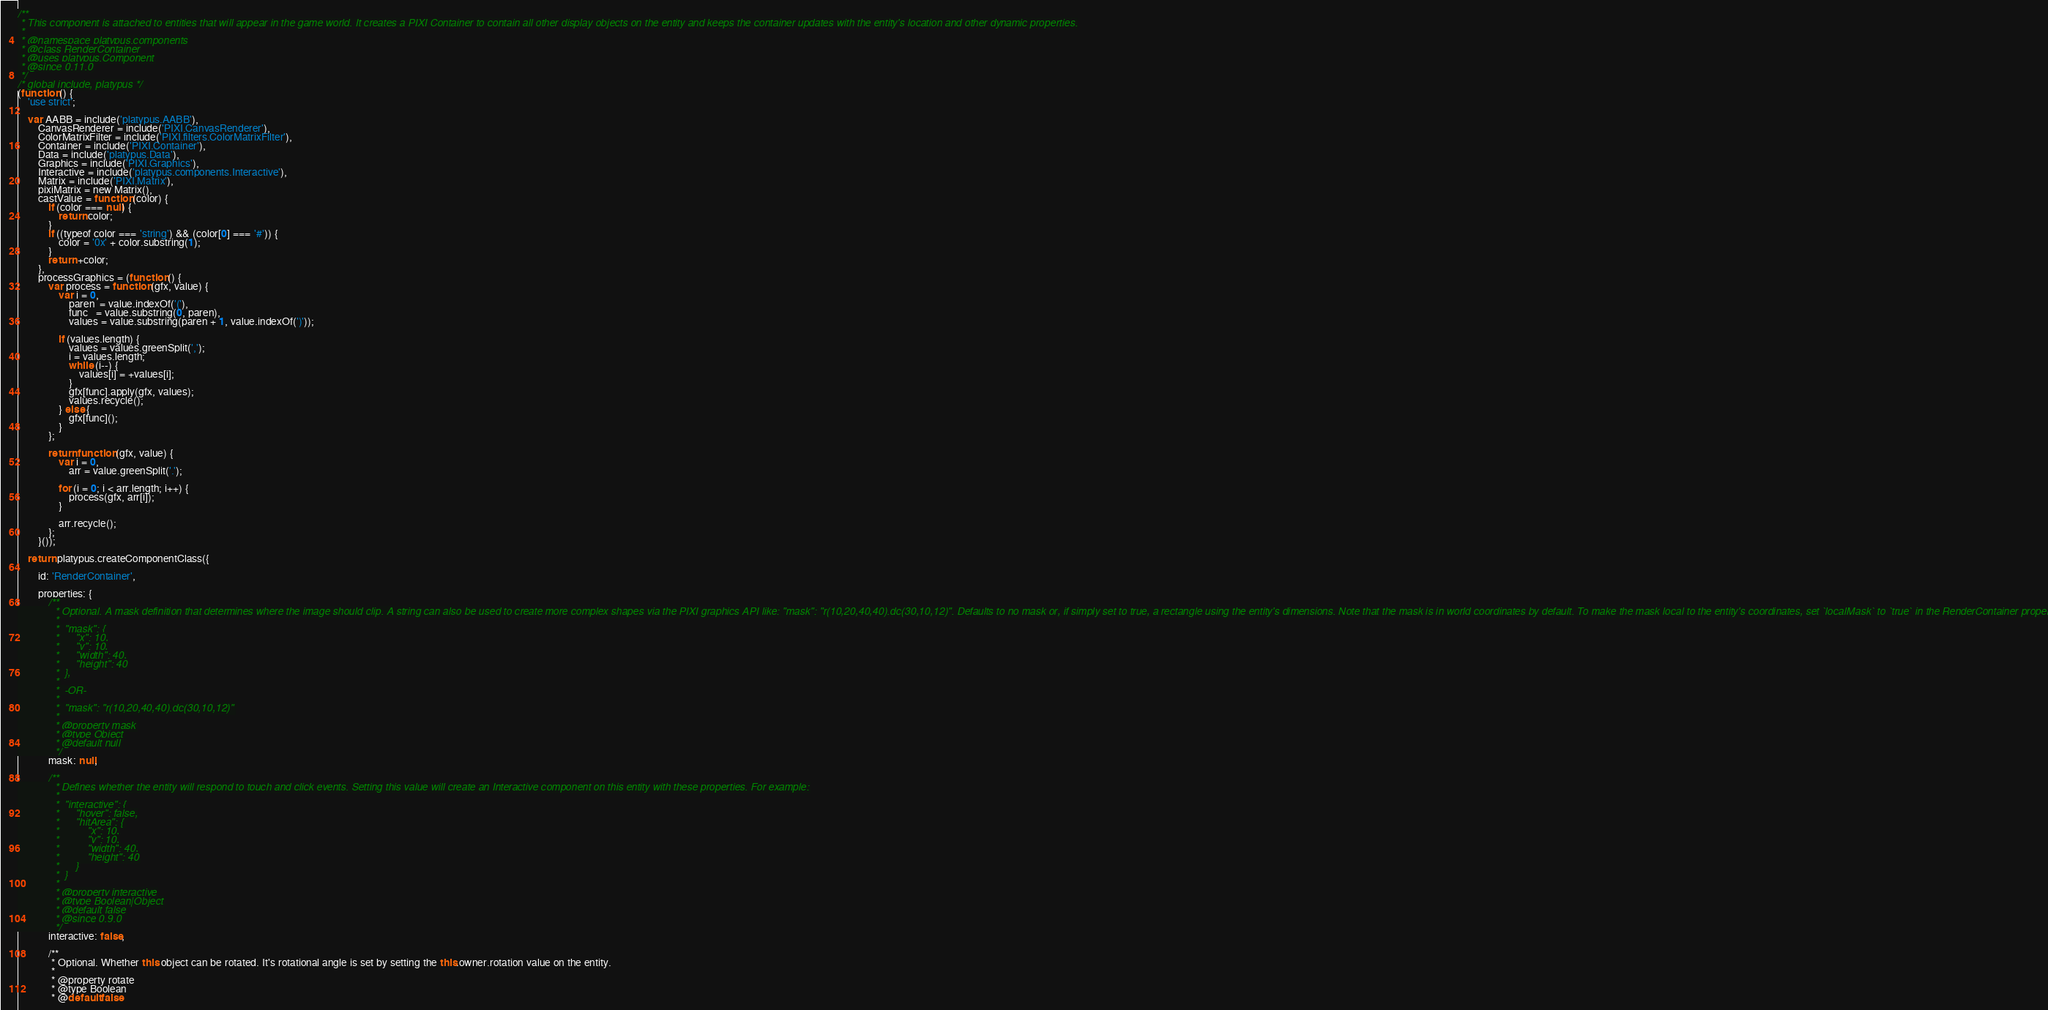<code> <loc_0><loc_0><loc_500><loc_500><_JavaScript_>/**
 * This component is attached to entities that will appear in the game world. It creates a PIXI Container to contain all other display objects on the entity and keeps the container updates with the entity's location and other dynamic properties.
 *
 * @namespace platypus.components
 * @class RenderContainer
 * @uses platypus.Component
 * @since 0.11.0
 */
/* global include, platypus */
(function () {
    'use strict';
    
    var AABB = include('platypus.AABB'),
        CanvasRenderer = include('PIXI.CanvasRenderer'),
        ColorMatrixFilter = include('PIXI.filters.ColorMatrixFilter'),
        Container = include('PIXI.Container'),
        Data = include('platypus.Data'),
        Graphics = include('PIXI.Graphics'),
        Interactive = include('platypus.components.Interactive'),
        Matrix = include('PIXI.Matrix'),
        pixiMatrix = new Matrix(),
        castValue = function (color) {
            if (color === null) {
                return color;
            }
            if ((typeof color === 'string') && (color[0] === '#')) {
                color = '0x' + color.substring(1);
            }
            return +color;
        },
        processGraphics = (function () {
            var process = function (gfx, value) {
                var i = 0,
                    paren  = value.indexOf('('),
                    func   = value.substring(0, paren),
                    values = value.substring(paren + 1, value.indexOf(')'));

                if (values.length) {
                    values = values.greenSplit(',');
                    i = values.length;
                    while (i--) {
                        values[i] = +values[i];
                    }
                    gfx[func].apply(gfx, values);
                    values.recycle();
                } else {
                    gfx[func]();
                }
            };

            return function (gfx, value) {
                var i = 0,
                    arr = value.greenSplit('.');

                for (i = 0; i < arr.length; i++) {
                    process(gfx, arr[i]);
                }
                
                arr.recycle();
            };
        }());
    
    return platypus.createComponentClass({
        
        id: 'RenderContainer',
        
        properties: {
            /**
             * Optional. A mask definition that determines where the image should clip. A string can also be used to create more complex shapes via the PIXI graphics API like: "mask": "r(10,20,40,40).dc(30,10,12)". Defaults to no mask or, if simply set to true, a rectangle using the entity's dimensions. Note that the mask is in world coordinates by default. To make the mask local to the entity's coordinates, set `localMask` to `true` in the RenderContainer properties.
             *
             *  "mask": {
             *      "x": 10,
             *      "y": 10,
             *      "width": 40,
             *      "height": 40
             *  },
             *
             *  -OR-
             *
             *  "mask": "r(10,20,40,40).dc(30,10,12)"
             *
             * @property mask
             * @type Object
             * @default null
             */
            mask: null,

            /**
             * Defines whether the entity will respond to touch and click events. Setting this value will create an Interactive component on this entity with these properties. For example:
             *
             *  "interactive": {
             *      "hover": false,
             *      "hitArea": {
             *          "x": 10,
             *          "y": 10,
             *          "width": 40,
             *          "height": 40
             *      }
             *  }
             *
             * @property interactive
             * @type Boolean|Object
             * @default false
             * @since 0.9.0
             */
            interactive: false,

            /**
             * Optional. Whether this object can be rotated. It's rotational angle is set by setting the this.owner.rotation value on the entity.
             *
             * @property rotate
             * @type Boolean
             * @default false</code> 